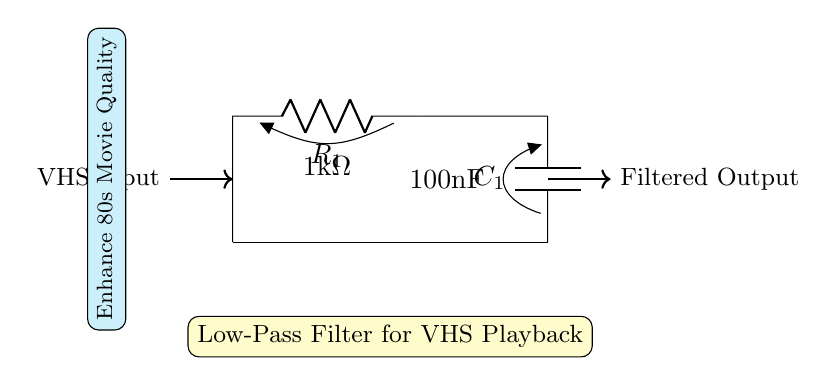What is the resistance value in this circuit? The resistance value is indicated on the circuit diagram next to the resistor symbol. It shows that R1 has a value of 1kΩ.
Answer: 1kΩ What is the capacitance value in this circuit? The capacitance value can be found next to the capacitor symbol in the circuit. It states that C1 has a value of 100nF.
Answer: 100nF What type of filter is represented in this circuit? The label within the yellow box states that the circuit is a low-pass filter, which allows low-frequency signals to pass through while attenuating high frequencies.
Answer: Low-Pass Filter What is the purpose of this filter circuit? Looking at the cyan box, it describes the function of the circuit, emphasizing enhancement of 80s movie playback quality, indicating that it is specifically tailored for VHS signals.
Answer: Enhance 80s Movie Quality How does this circuit affect high frequencies? Since it is a low-pass filter, it is designed to reduce or block high-frequency signals. The presence of the resistor and capacitor creates a cutoff frequency that attenuates these signals.
Answer: Reduces high frequencies What is the input to this circuit? The circuit diagram labels an arrow with the term "VHS Input," indicating that the input signal comes directly from a VHS player or tape.
Answer: VHS Input What components make up this low-pass filter? The circuit diagram includes a resistor and a capacitor, which are the essential components used to construct the low-pass filter functionality.
Answer: Resistor and Capacitor 